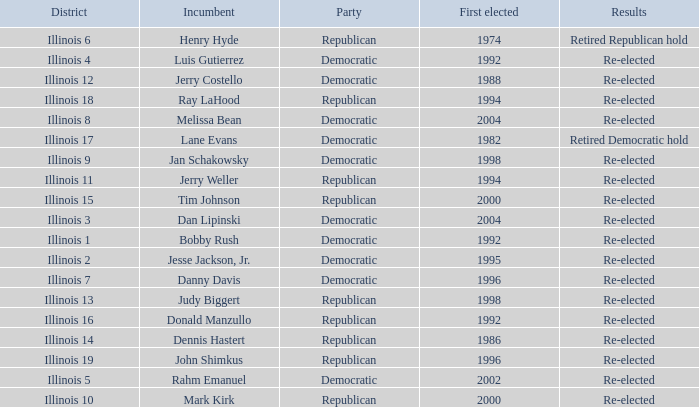What is re-elected Incumbent Jerry Costello's First elected date? 1988.0. 